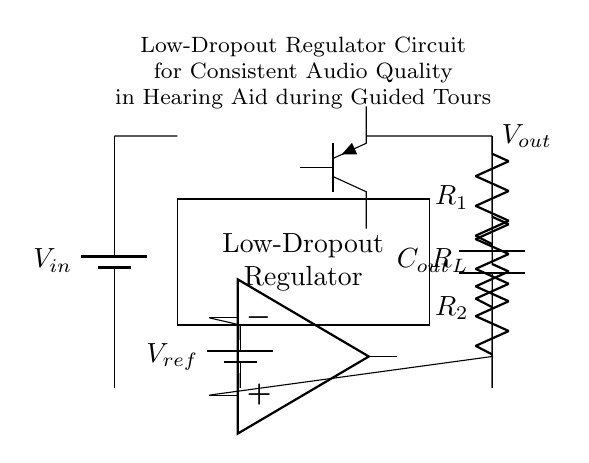What is the function of the component labeled "Vref"? The component labeled "Vref" is a reference voltage source that provides a constant voltage to the error amplifier, helping to maintain stability in the output voltage of the regulator.
Answer: Reference voltage What does "R_L" represent in the circuit? "R_L" represents the load resistor, which is the component that connects to the output to simulate the load that the regulator will be driving.
Answer: Load resistor What is the role of the Op Amp in this circuit? The Op Amp is used as an error amplifier that compares the output voltage with the reference voltage and adjusts the pass transistor's operation to regulate the output voltage accordingly.
Answer: Error amplifier How many resistors are used in the feedback loop? There are two resistors, labeled "R_1" and "R_2", which form a voltage divider that helps set the output voltage based on the feedback from the output.
Answer: Two What type of transistor is used in the regulator circuit? The circuit employs a PNP transistor as the pass element that helps regulate the voltage by adjusting the current flowing to the output based on the error amplifier's input.
Answer: PNP transistor What is the purpose of the capacitor labeled "C_out"? "C_out" serves as a decoupling capacitor, smoothing out any variations in the output voltage, thereby ensuring a stable and consistent audio quality for the hearing aid during guided tours.
Answer: Decoupling capacitor 